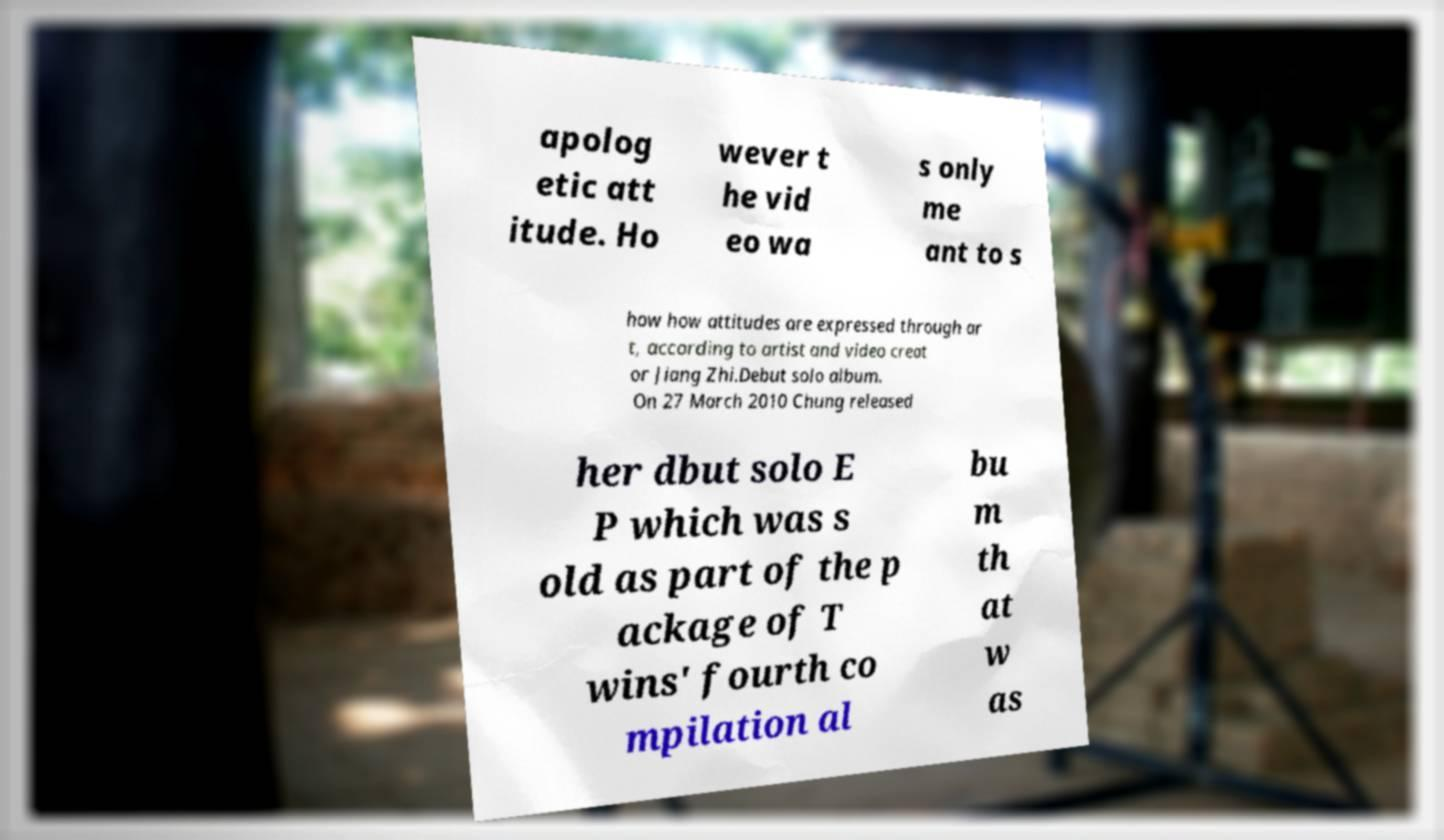Can you accurately transcribe the text from the provided image for me? apolog etic att itude. Ho wever t he vid eo wa s only me ant to s how how attitudes are expressed through ar t, according to artist and video creat or Jiang Zhi.Debut solo album. On 27 March 2010 Chung released her dbut solo E P which was s old as part of the p ackage of T wins' fourth co mpilation al bu m th at w as 